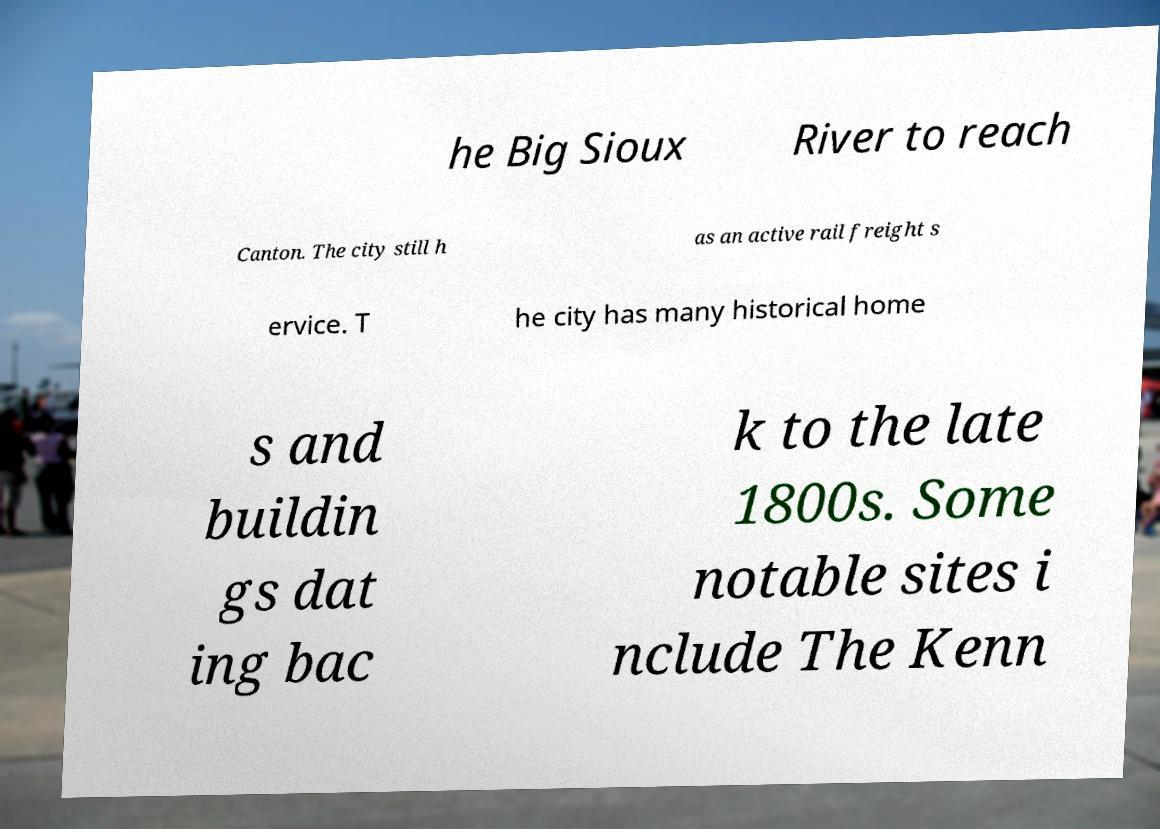For documentation purposes, I need the text within this image transcribed. Could you provide that? he Big Sioux River to reach Canton. The city still h as an active rail freight s ervice. T he city has many historical home s and buildin gs dat ing bac k to the late 1800s. Some notable sites i nclude The Kenn 